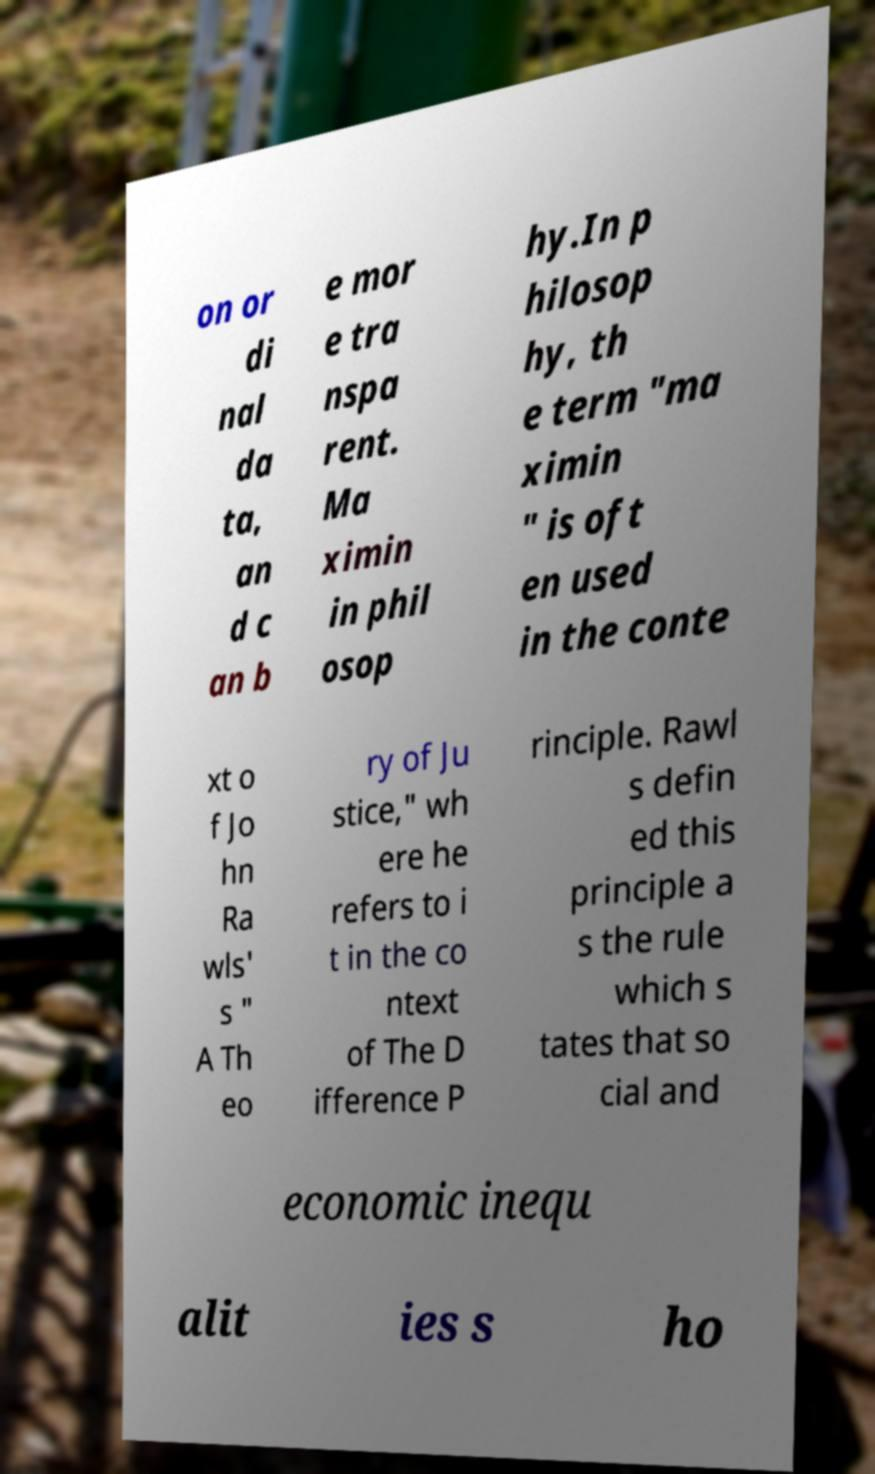There's text embedded in this image that I need extracted. Can you transcribe it verbatim? on or di nal da ta, an d c an b e mor e tra nspa rent. Ma ximin in phil osop hy.In p hilosop hy, th e term "ma ximin " is oft en used in the conte xt o f Jo hn Ra wls' s " A Th eo ry of Ju stice," wh ere he refers to i t in the co ntext of The D ifference P rinciple. Rawl s defin ed this principle a s the rule which s tates that so cial and economic inequ alit ies s ho 